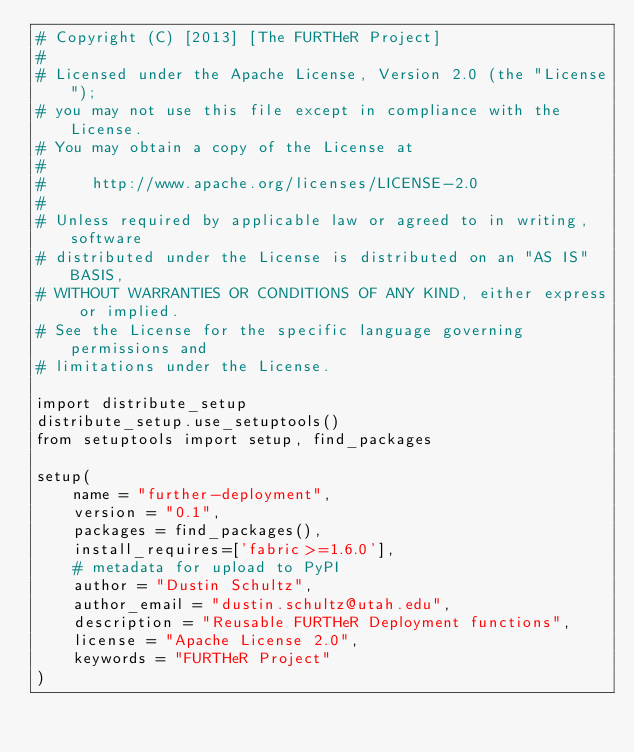Convert code to text. <code><loc_0><loc_0><loc_500><loc_500><_Python_># Copyright (C) [2013] [The FURTHeR Project]
#
# Licensed under the Apache License, Version 2.0 (the "License");
# you may not use this file except in compliance with the License.
# You may obtain a copy of the License at
#
#     http://www.apache.org/licenses/LICENSE-2.0
#
# Unless required by applicable law or agreed to in writing, software
# distributed under the License is distributed on an "AS IS" BASIS,
# WITHOUT WARRANTIES OR CONDITIONS OF ANY KIND, either express or implied.
# See the License for the specific language governing permissions and
# limitations under the License.

import distribute_setup
distribute_setup.use_setuptools()
from setuptools import setup, find_packages

setup(
    name = "further-deployment",
    version = "0.1",
    packages = find_packages(),
    install_requires=['fabric>=1.6.0'],
    # metadata for upload to PyPI
    author = "Dustin Schultz",
    author_email = "dustin.schultz@utah.edu",
    description = "Reusable FURTHeR Deployment functions",
    license = "Apache License 2.0",
    keywords = "FURTHeR Project"
)
</code> 